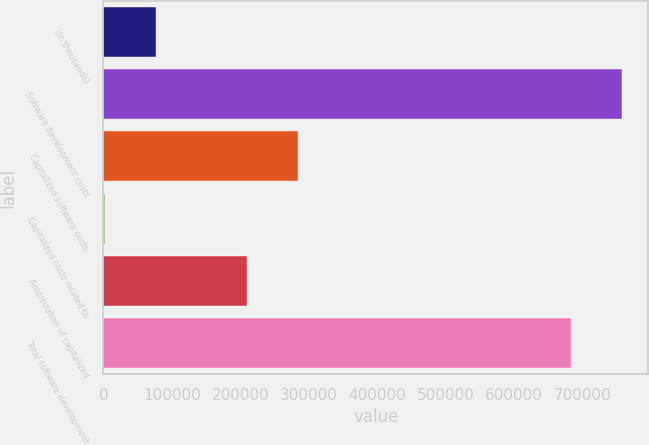Convert chart to OTSL. <chart><loc_0><loc_0><loc_500><loc_500><bar_chart><fcel>(In thousands)<fcel>Software development costs<fcel>Capitalized software costs<fcel>Capitalized costs related to<fcel>Amortization of capitalized<fcel>Total software development<nl><fcel>76428.2<fcel>758185<fcel>284750<fcel>1906<fcel>210228<fcel>683663<nl></chart> 